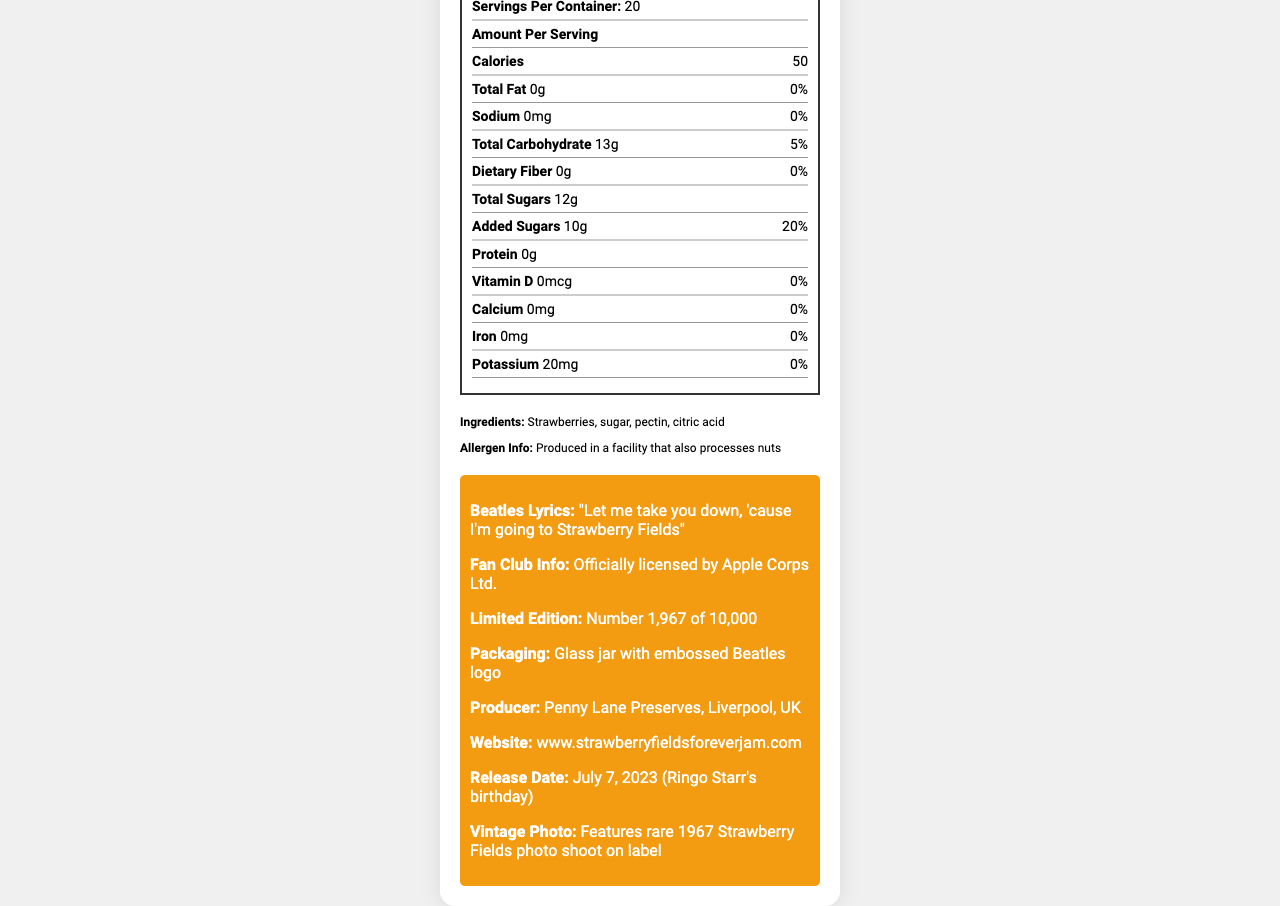what is the serving size of the Strawberry Fields Forever Jam? The document specifies "Serving Size: 1 tablespoon (20g)" in the nutrition facts section.
Answer: 1 tablespoon (20g) how many servings are there per container? The document lists "Servings Per Container: 20" in the nutrition facts section.
Answer: 20 how many calories are there per serving? The document indicates that each serving contains "Calories: 50" in the nutrition facts.
Answer: 50 what is the total carbohydrate content per serving? According to the document, the "Total Carbohydrate" content per serving is 13g.
Answer: 13g what allergens are processed in the facility where this jam is made? The document states, "Allergen Info: Produced in a facility that also processes nuts".
Answer: Nuts how much added sugar is in one serving? The document states that the "Added Sugars" amount is 10g per serving.
Answer: 10g who is the producer of this strawberry jam? The document mentions that the producer is "Penny Lane Preserves, Liverpool, UK".
Answer: Penny Lane Preserves, Liverpool, UK where can you find more information about this product online? The document provides the website link as "www.strawberryfieldsforeverjam.com".
Answer: www.strawberryfieldsforeverjam.com how much sodium does this jam contain per serving? A. 0mg B. 10mg C. 20mg D. 30mg The document states "Sodium: 0mg" per serving.
Answer: A. 0mg which of the following nutrients has the highest daily value percentage per serving? A. Total Fat B. Sodium C. Added Sugars D. Vitamin D According to the document, "Added Sugars" have the highest daily value percentage of "20%" per serving.
Answer: C. Added Sugars is this product fan club exclusive? The document states that it is "Fan Club Exclusive: true".
Answer: Yes is it possible to determine the protein content in this jam from the document? The document clearly lists "Protein: 0g" in the nutrition facts section.
Answer: Yes please summarize the main idea of this document. The document primarily outlines the nutritional content and additional features of the "Strawberry Fields Forever Jam," making it clear to consumers what they are consuming and the special features included in this limited edition product.
Answer: This document provides detailed nutrition facts for "Strawberry Fields Forever Jam," including serving size, calorie content, and nutrient information. It also provides information about its ingredients, allergen info, Beatles lyrics printed on the jar, packaging, producer, and a vintage photo feature. The product is fan club exclusive and officially licensed. is the release date of this product mentioned? The document specifies the release date as "July 7, 2023 (Ringo Starr's birthday)".
Answer: Yes what is the percentage of dietary fiber per serving? The document lists the daily value of "Dietary Fiber" as "0%" per serving.
Answer: 0% does this jam contain any Vitamin D? The document specifies "Vitamin D: 0mcg 0%" indicating there is no Vitamin D in this jam.
Answer: No how much potassium is in each serving of this jam? The document specifies that the "Potassium" content per serving is 20mg.
Answer: 20mg how many grams of total sugars are in one serving? The document shows that the "Total Sugars" per serving amount to 12g.
Answer: 12g which Beatles lyric is printed on the jar? The document states the Beatles lyric printed on the jar as "Let me take you down, 'cause I'm going to Strawberry Fields".
Answer: "Let me take you down, 'cause I'm going to Strawberry Fields" how much calcium per serving does this jam have? The document lists "Calcium: 0mg" per serving.
Answer: 0mg 